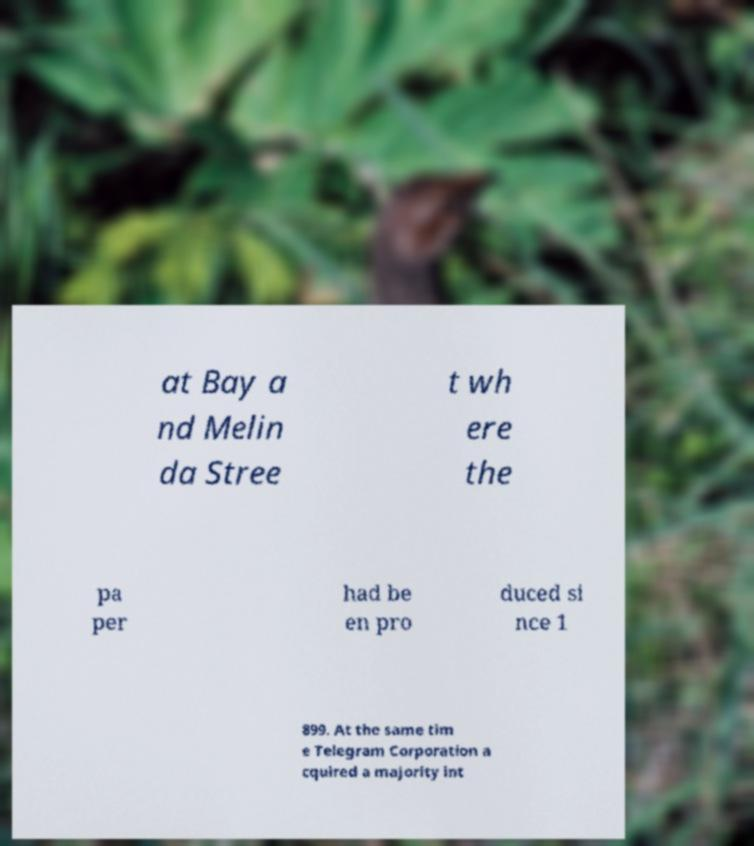Please read and relay the text visible in this image. What does it say? at Bay a nd Melin da Stree t wh ere the pa per had be en pro duced si nce 1 899. At the same tim e Telegram Corporation a cquired a majority int 